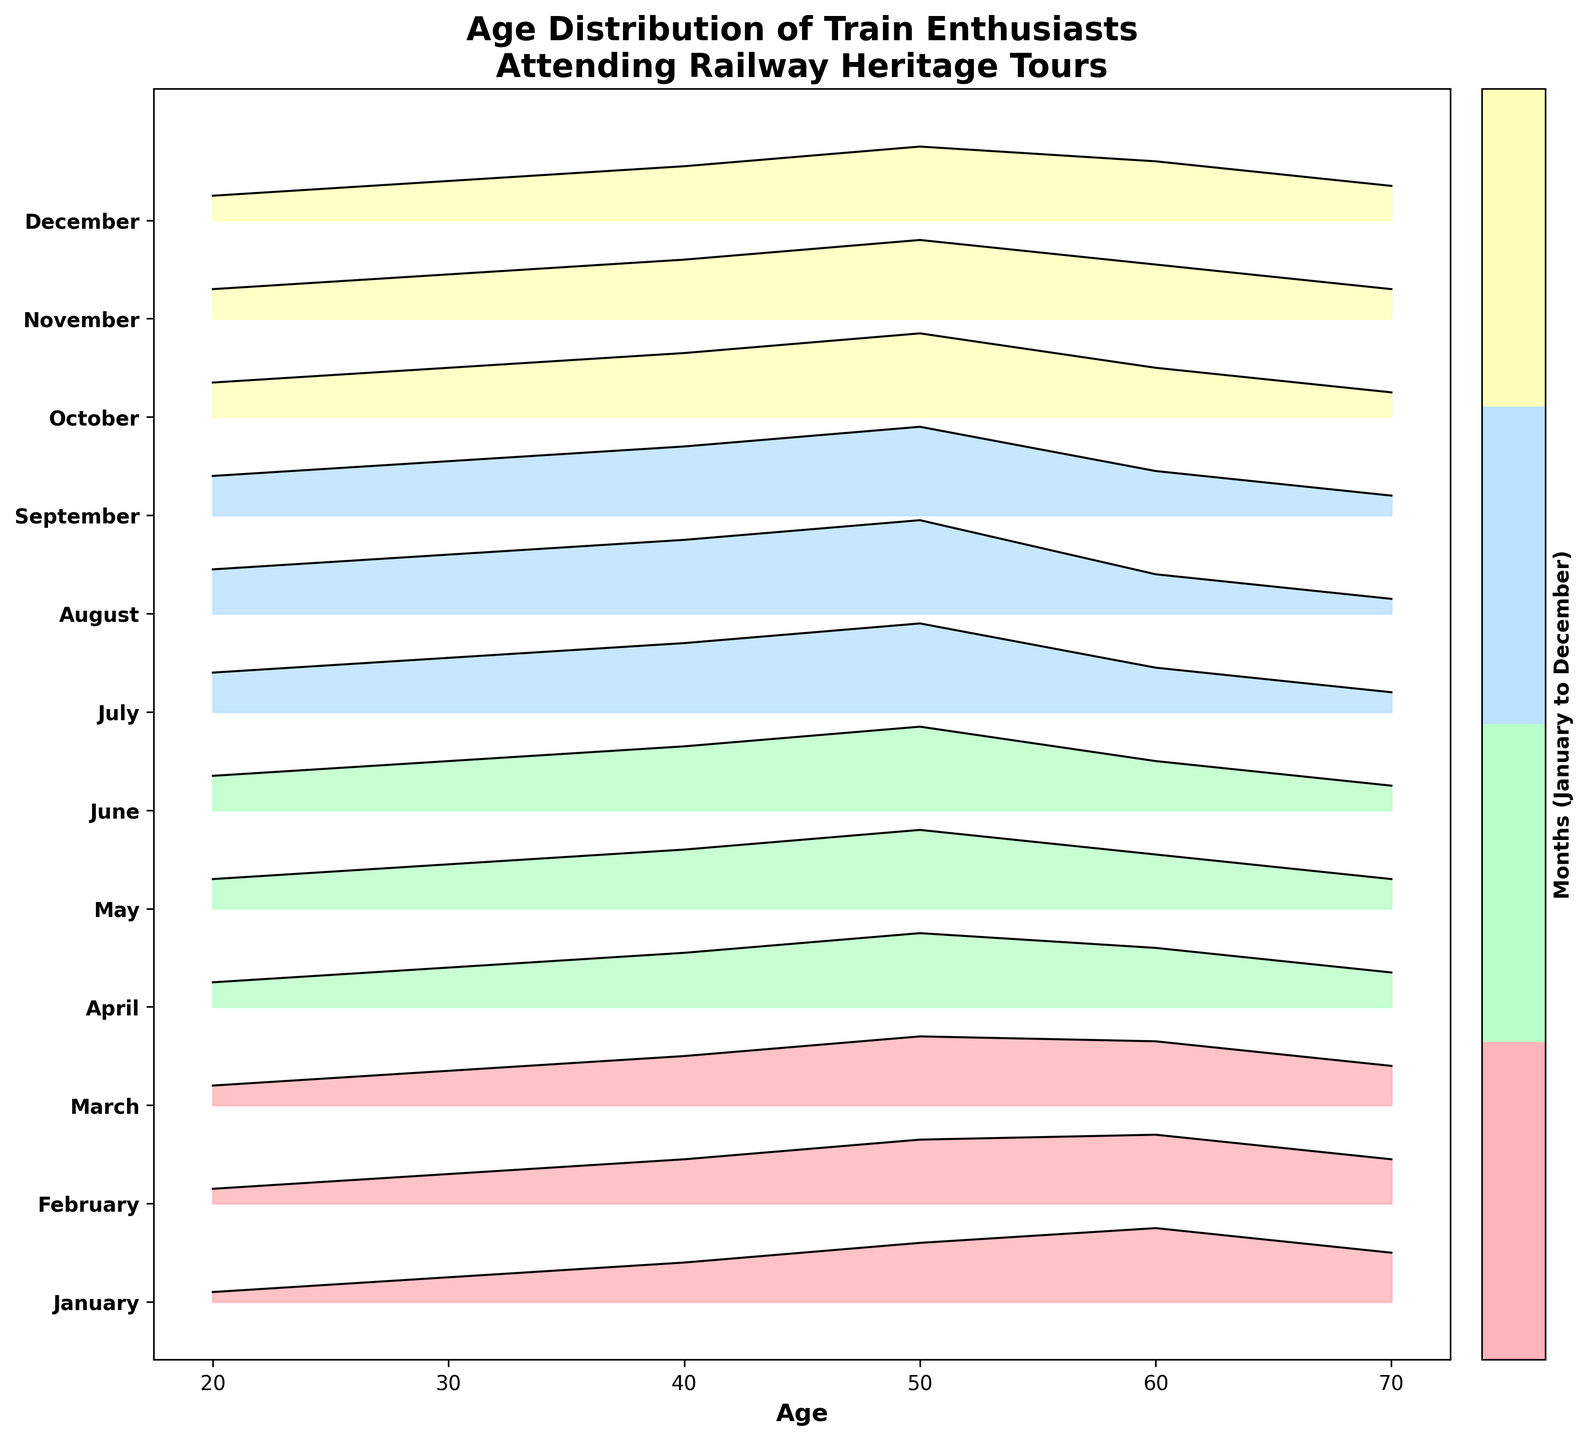What's the title of the figure? The title is displayed at the top of the plot. It provides context to what the plot is illustrating.
Answer: Age Distribution of Train Enthusiasts Attending Railway Heritage Tours How many age groups are displayed in the figure? Count the unique age groups along the x-axis.
Answer: 6 Which month has the highest density for the age group 50? Look at the ridgelines for each month at the age 50 mark on the x-axis, then identify the highest density value.
Answer: August What is the general trend of age distributions from January to December? Observe how the peaks of the ridgelines shift and change across the months.
Answer: The peak density gradually shifts from older to younger age groups throughout the year In which month do we see the lowest density for the age group 70? Look at the ridgelines for each month at the age 70 mark on the x-axis, then identify the lowest density value.
Answer: August Compare the density for age 60 in January and October. Which is higher? Find the corresponding ridgelines for January and October at age 60 and compare their heights.
Answer: January What is the densest age group in March? Find the peak of the ridgeline for March and note the corresponding age group.
Answer: 50 Identify the months where the age group 20 is most represented. Look for the months where the ridgelines for age 20 have their highest values.
Answer: August, September What is the range of density values for age group 40 in June? Observe the density value for age 40 in June along the y-axis.
Answer: 0 to 0.65 How do the densities for age groups 30 and 40 compare in July? Compare the height of the ridgelines for age groups 30 and 40 in July.
Answer: Age group 40 has a higher density than age group 30 